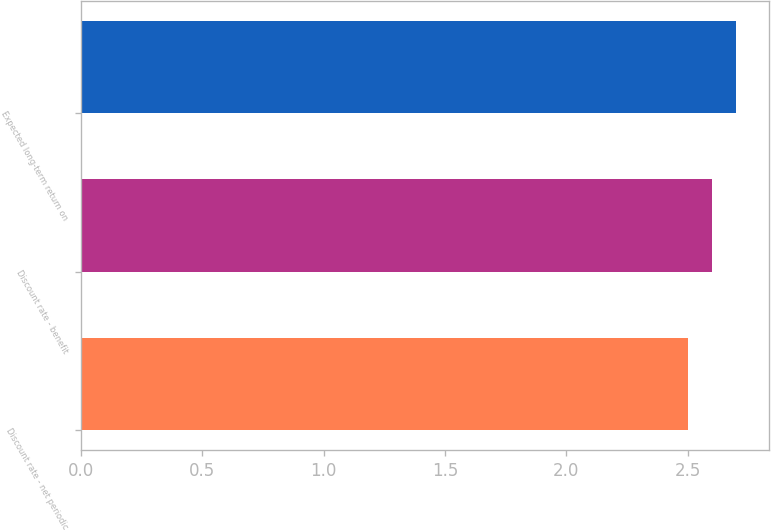Convert chart. <chart><loc_0><loc_0><loc_500><loc_500><bar_chart><fcel>Discount rate - net periodic<fcel>Discount rate - benefit<fcel>Expected long-term return on<nl><fcel>2.5<fcel>2.6<fcel>2.7<nl></chart> 